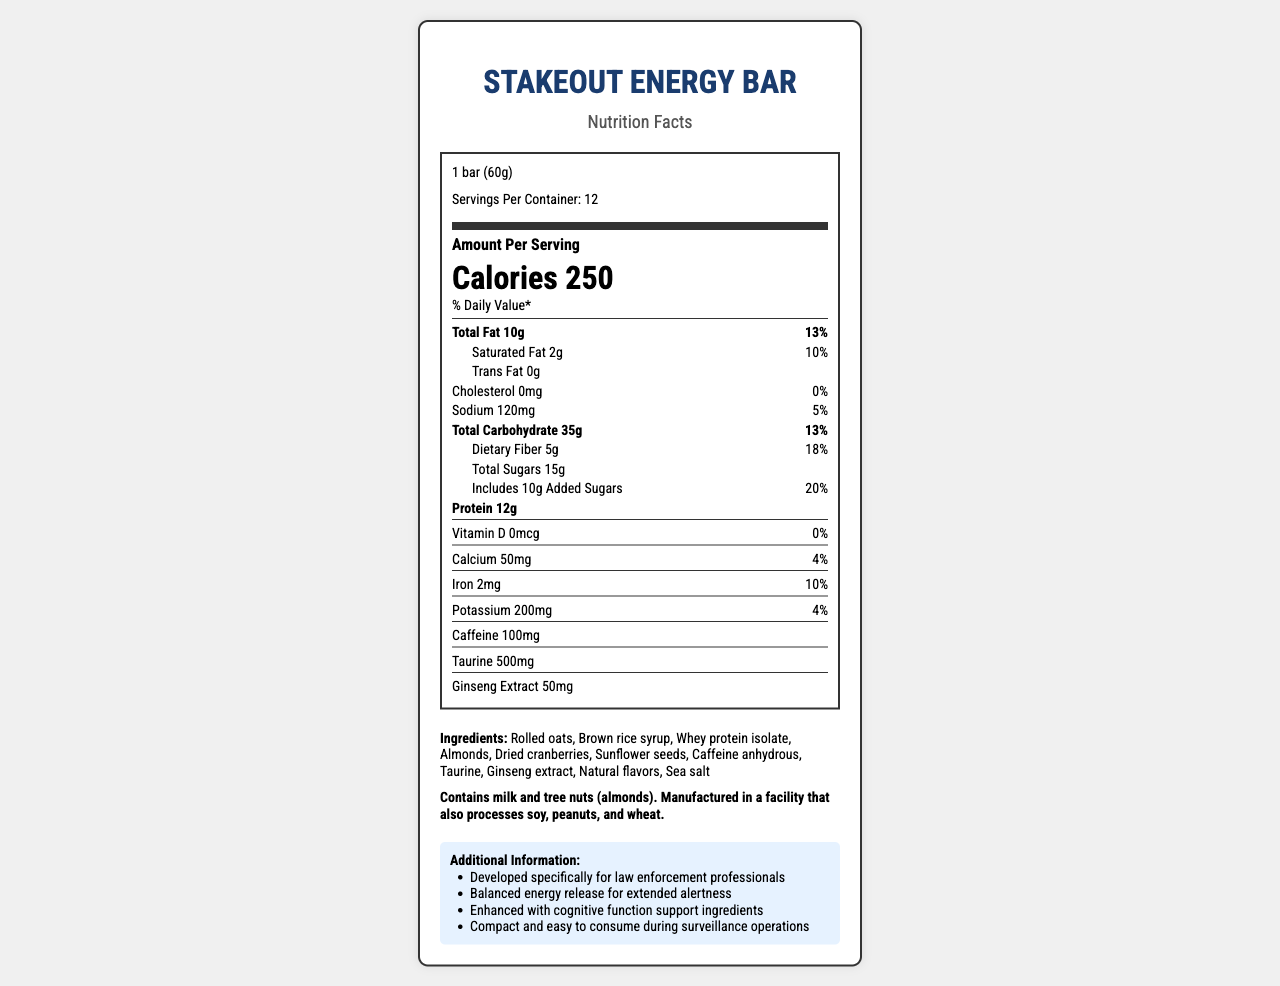what is the serving size for the StakeOut Energy Bar? The serving size is listed at the top of the Nutrition Facts with the label "Serving Size: 1 bar (60g)."
Answer: 1 bar (60g) how many calories are in one serving of the StakeOut Energy Bar? The calories per serving are listed prominently in the middle of the Nutrition Facts section with the label "Calories."
Answer: 250 how many grams of protein does each bar contain? The amount of protein per bar is listed in the Nutrition Facts under "Protein" with the amount "12g."
Answer: 12g how much caffeine is in one bar? The caffeine content per bar is listed under the vitamins and minerals section with "Caffeine 100mg."
Answer: 100mg how should the StakeOut Energy Bar be stored? The storage instructions are listed at the bottom of the document under "storage instructions."
Answer: Store in a cool, dry place. Consume within 12 months of production date. how many servings are there in one container? A. 6 B. 12 C. 24 D. 8 The number of servings per container is listed at the top of the Nutrition Facts with the label "Servings Per Container: 12."
Answer: B. 12 what is the daily value percentage for dietary fiber? A. 5% B. 10% C. 18% D. 20% The daily value percentage for dietary fiber is listed in the Nutrition Facts section as "Dietary Fiber 5g 18%."
Answer: C. 18% does the StakeOut Energy Bar contain any trans fat? The trans fat content is listed in the Nutrition Facts under "Trans Fat" and is marked as "0g."
Answer: No describe the main benefits of the StakeOut Energy Bar mentioned in the additional information section. The additional benefits are listed in the "Additional Information" section at the bottom of the document, which includes points about energy release, cognitive function support, and its convenience for law enforcement professionals.
Answer: The bar is designed specifically for law enforcement professionals, provides balanced energy release for extended alertness, supports cognitive function, and is compact and easy to consume during surveillance operations. are there any tree nuts in the StakeOut Energy Bar? The allergen information at the bottom of the document states that the bar contains tree nuts (specifically almonds).
Answer: Yes is there any information about the sodium content? If so, what is it? The sodium content is listed in the Nutrition Facts as "Sodium 120mg" with a daily value of "5%."
Answer: Yes, 120mg (5% daily value) what is the total carbohydrate content per serving? The total carbohydrate content is listed in the Nutrition Facts as "Total Carbohydrate 35g" with a daily value of "13%."
Answer: 35g (13% daily value) how many types of ingredients are used in making the StakeOut Energy Bar? The list of ingredients at the bottom of the document contains 11 items.
Answer: 11 is there Vitamin D in the StakeOut Energy Bar? The Nutrition Facts section lists "Vitamin D 0mcg" with a daily value of "0%."
Answer: No what is the source of protein in the StakeOut Energy Bar? The ingredient list includes "Whey protein isolate," which is the source of protein.
Answer: Whey protein isolate who is the manufacturer of the StakeOut Energy Bar? The manufacturer information at the bottom of the document lists "FedFuel Nutrition, Inc."
Answer: FedFuel Nutrition, Inc. how much taurine is in each bar? The amount of taurine per bar is listed in the vitamins and minerals section as "Taurine 500mg."
Answer: 500mg which of the following is not an ingredient in the StakeOut Energy Bar? A. Whey protein isolate B. Almonds C. Ginseng extract D. Peanut butter The ingredient list does not mention peanut butter; the listed ingredients are "Rolled oats, Brown rice syrup, Whey protein isolate, Almonds, Dried cranberries, Sunflower seeds, Caffeine anhydrous, Taurine, Ginseng extract, Natural flavors, Sea salt."
Answer: D. Peanut butter how many grams of added sugars does the StakeOut Energy Bar have per serving? The added sugars content is listed in the Nutrition Facts as "Includes 10g Added Sugars" with a daily value of "20%."
Answer: 10g does the StakeOut Energy Bar support cognitive function? The additional information section states that it is "Enhanced with cognitive function support ingredients."
Answer: Yes what is the exact production date of the StakeOut Energy Bar? The document does not specify the production date; it only mentions that the product should be consumed within 12 months of production.
Answer: Not enough information 